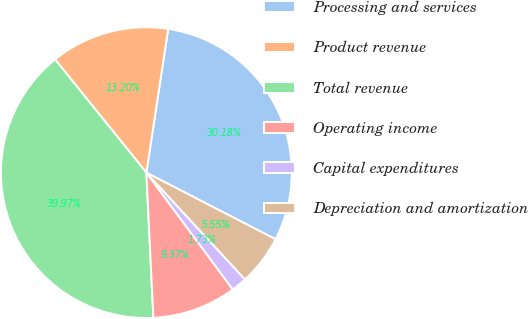Convert chart. <chart><loc_0><loc_0><loc_500><loc_500><pie_chart><fcel>Processing and services<fcel>Product revenue<fcel>Total revenue<fcel>Operating income<fcel>Capital expenditures<fcel>Depreciation and amortization<nl><fcel>30.18%<fcel>13.2%<fcel>39.97%<fcel>9.37%<fcel>1.73%<fcel>5.55%<nl></chart> 